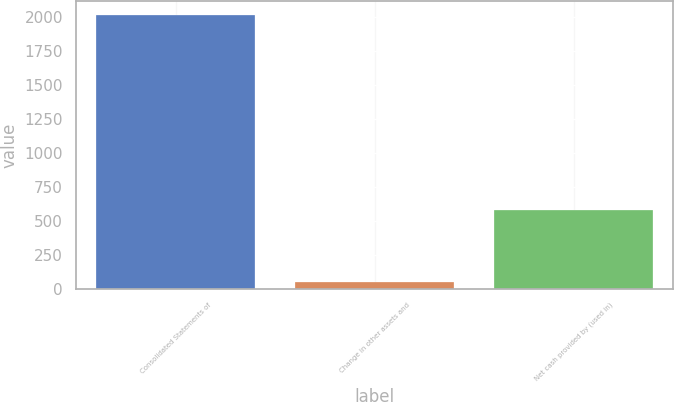Convert chart. <chart><loc_0><loc_0><loc_500><loc_500><bar_chart><fcel>Consolidated Statements of<fcel>Change in other assets and<fcel>Net cash provided by (used in)<nl><fcel>2016<fcel>45.6<fcel>581.5<nl></chart> 